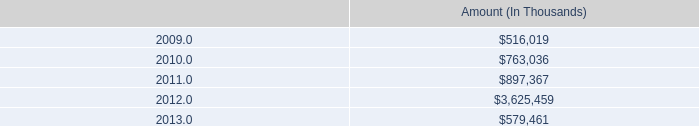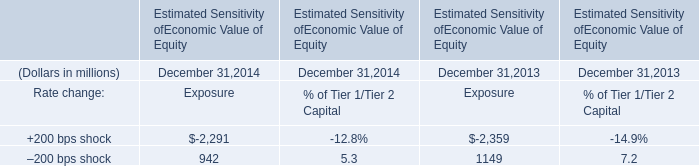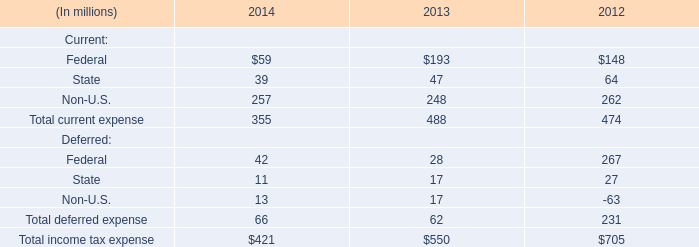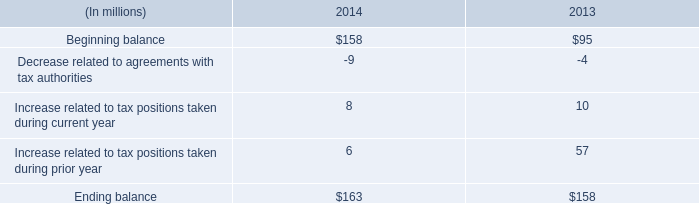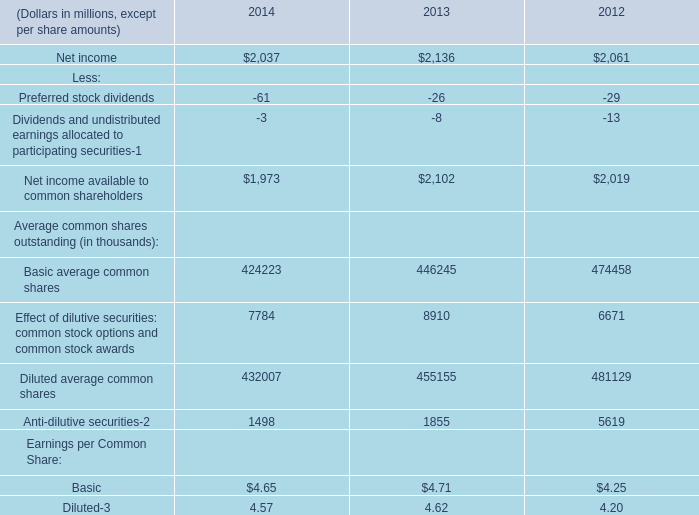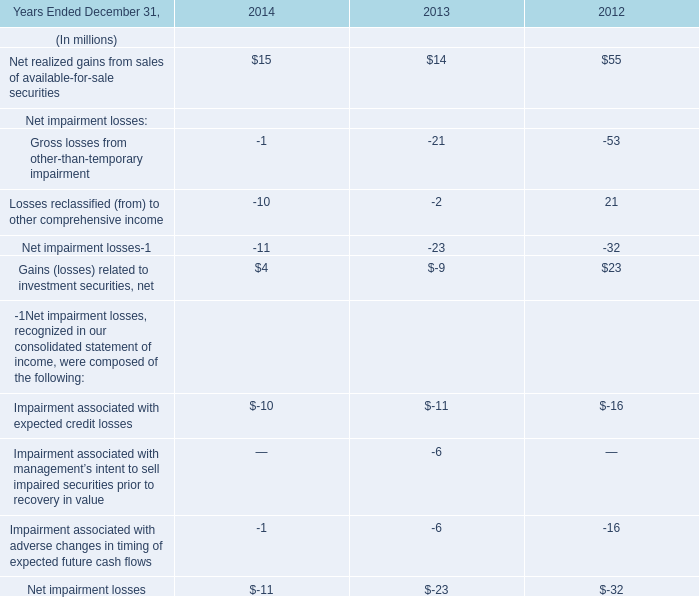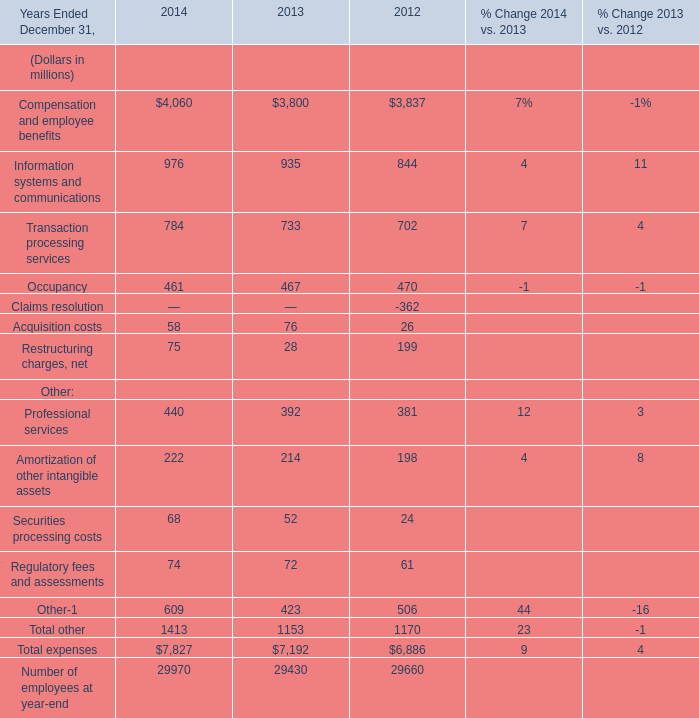What's the current increasing rate of Net realized gains from sales of available-for-sale securities? 
Computations: ((15 - 14) / 14)
Answer: 0.07143. 